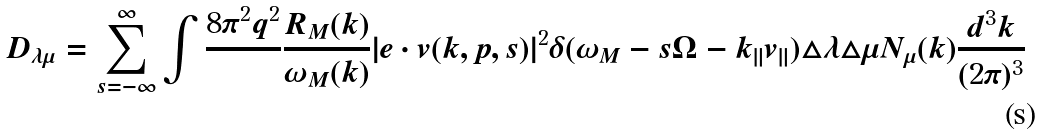Convert formula to latex. <formula><loc_0><loc_0><loc_500><loc_500>D _ { \lambda \mu } = \sum _ { s = - \infty } ^ { \infty } \int \frac { 8 \pi ^ { 2 } q ^ { 2 } } { } \frac { R _ { M } ( { k } ) } { \omega _ { M } ( { k } ) } | { e } \cdot { v } ( { k } , { p } , s ) | ^ { 2 } \delta ( \omega _ { M } - s \Omega - k _ { \| } v _ { \| } ) \triangle \lambda \triangle \mu N _ { \mu } ( { k } ) \frac { d ^ { 3 } k } { ( 2 \pi ) ^ { 3 } }</formula> 